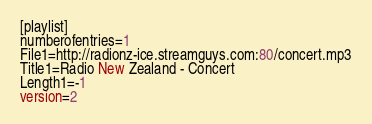<code> <loc_0><loc_0><loc_500><loc_500><_SQL_>[playlist]
numberofentries=1
File1=http://radionz-ice.streamguys.com:80/concert.mp3
Title1=Radio New Zealand - Concert
Length1=-1
version=2
</code> 